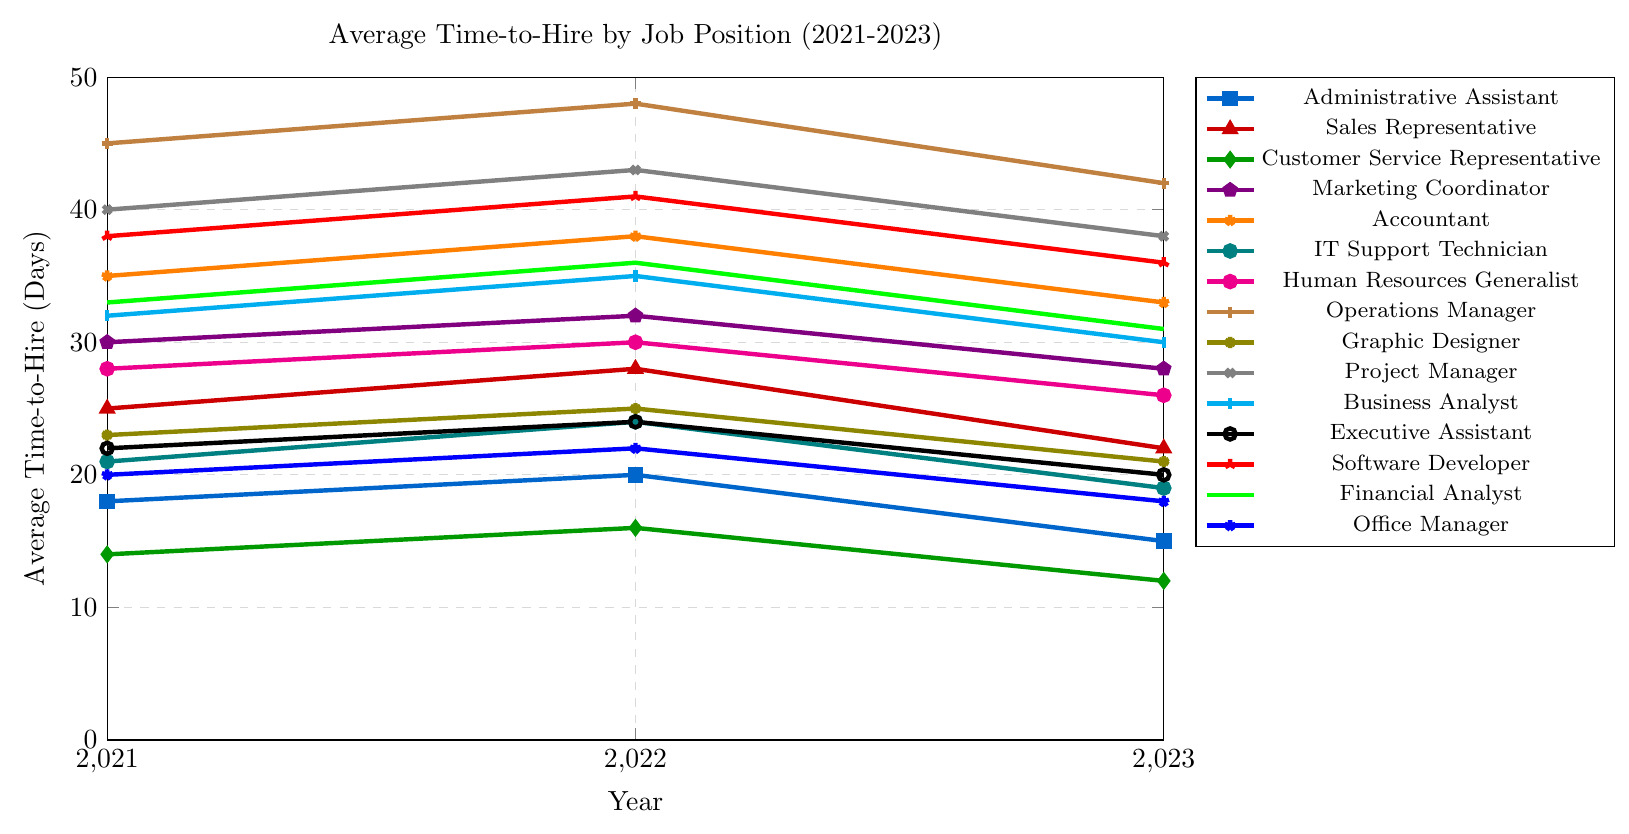What's the job position with the fastest decrease in average time-to-hire from 2022 to 2023? To find this, we need to subtract the 2023 value from the 2022 value for each job position and identify the one with the largest positive difference. Here's the calculation: Administrative Assistant (20-15=5), Sales Representative (28-22=6), Customer Service Representative (16-12=4), Marketing Coordinator (32-28=4), Accountant (38-33=5), IT Support Technician (24-19=5), Human Resources Generalist (30-26=4), Operations Manager (48-42=6), Graphic Designer (25-21=4), Project Manager (43-38=5), Business Analyst (35-30=5), Executive Assistant (24-20=4), Software Developer (41-36=5), Financial Analyst (36-31=5), Office Manager (22-18=4). Sales Representative and Operations Manager have the highest decrease of 6 days.
Answer: Sales Representative and Operations Manager Which job position consistently had the highest average time-to-hire over the three years? We need to look at the highest value for each year and see if any job position appears consistently. In 2021, Operations Manager (45 days), in 2022, Operations Manager (48 days), in 2023, Operations Manager again (42 days).
Answer: Operations Manager By how many days did the time-to-hire for an Accountant decrease from 2022 to 2023? The average time-to-hire for an Accountant was 38 days in 2022 and 33 days in 2023. Subtract 33 from 38 to find the difference.
Answer: 5 days What is the average time-to-hire for a Marketing Coordinator across the three years? The values for Marketing Coordinator are 30 in 2021, 32 in 2022, and 28 in 2023. The average is (30 + 32 + 28) / 3 = 90 / 3 = 30.
Answer: 30 days Which two job positions shared the same average time-to-hire in 2022? Check the 2022 values for job positions that are identical. Sales Representative and Operations Manager both had 28 days.
Answer: Sales Representative and Operations Manager Which job position had the smallest variation in average time-to-hire over the three years? Calculate the range (difference between max and min values) for each job position. Administrative Assistant (max = 20, min = 15, range = 5), Sales Representative (max = 28, min = 22, range = 6), Customer Service Representative (max = 16, min = 12, range = 4), ... Identify the smallest range.
Answer: Customer Service Representative Which job position had an increase in average time-to-hire from 2021 to 2022 and then a decrease from 2022 to 2023? Look for job positions where the trend increases first and then decreases. For example, the Administrative Assistant increased from 18 to 20 in 2021-2022 and then decreased from 20 to 15 in 2022-2023.
Answer: Administrative Assistant, Sales Representative, IT Support Technician, Human Resources Generalist, Graphic Designer, Executive Assistant, Software Developer, Financial Analyst, Office Manager What's the combined decrease in average time-to-hire from 2022 to 2023 for all the positions? To find this, sum up the decreases for each position from 2022 to 2023. (20-15) + (28-22) + (16-12) + (32-28) + (38-33) + (24-19) + (30-26) + (48-42) + (25-21) + (43-38) + (35-30) + (24-20) + (41-36) + (36-31) + (22-18). Total = 5 + 6 + 4 + 4 + 5 + 5 + 4 + 6 + 4 + 5 + 5 + 4 + 5 + 5 + 4 = 71.
Answer: 71 days What’s the average time-to-hire for all job positions in 2023? Sum all the 2023 values and divide by the number of job positions, which is 15. (15 + 22 + 12 + 28 + 33 + 19 + 26 + 42 + 21 + 38 + 30 + 20 + 36 + 31 + 18) / 15 = 391 / 15 = 26.07.
Answer: 26.07 days 